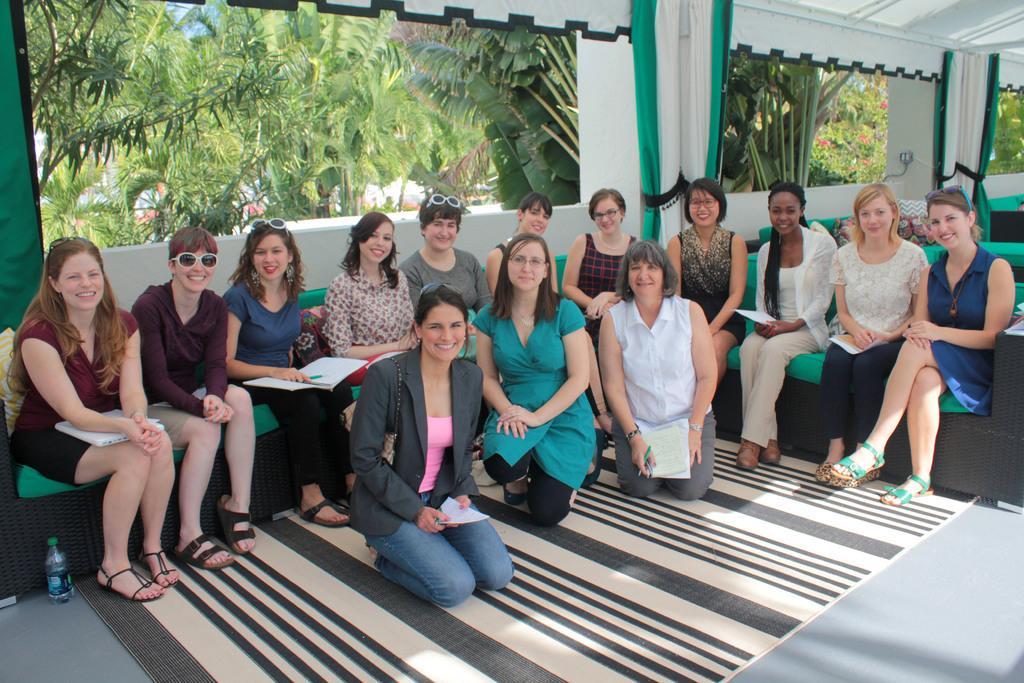Please provide a concise description of this image. In the middle I can see a group of women's are sitting on the sofa and on the floor. In the background I can see trees, wall, curtains and a fence. This image is taken during a day. 